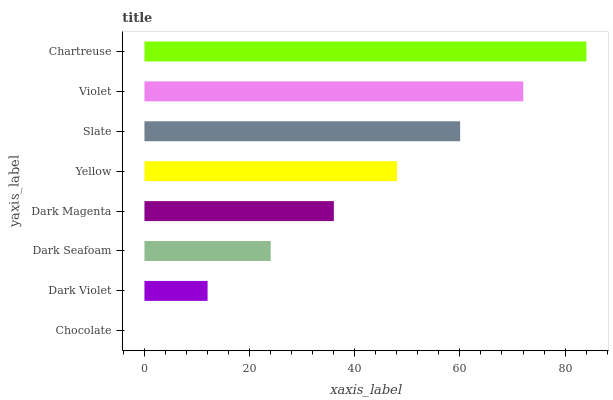Is Chocolate the minimum?
Answer yes or no. Yes. Is Chartreuse the maximum?
Answer yes or no. Yes. Is Dark Violet the minimum?
Answer yes or no. No. Is Dark Violet the maximum?
Answer yes or no. No. Is Dark Violet greater than Chocolate?
Answer yes or no. Yes. Is Chocolate less than Dark Violet?
Answer yes or no. Yes. Is Chocolate greater than Dark Violet?
Answer yes or no. No. Is Dark Violet less than Chocolate?
Answer yes or no. No. Is Yellow the high median?
Answer yes or no. Yes. Is Dark Magenta the low median?
Answer yes or no. Yes. Is Dark Seafoam the high median?
Answer yes or no. No. Is Slate the low median?
Answer yes or no. No. 